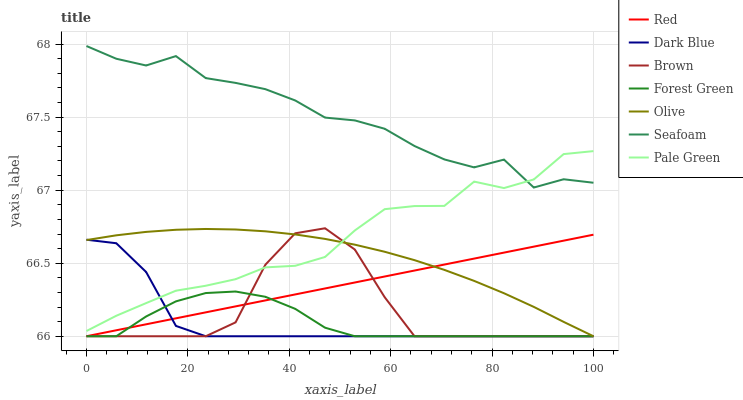Does Dark Blue have the minimum area under the curve?
Answer yes or no. Yes. Does Seafoam have the maximum area under the curve?
Answer yes or no. Yes. Does Seafoam have the minimum area under the curve?
Answer yes or no. No. Does Dark Blue have the maximum area under the curve?
Answer yes or no. No. Is Red the smoothest?
Answer yes or no. Yes. Is Seafoam the roughest?
Answer yes or no. Yes. Is Dark Blue the smoothest?
Answer yes or no. No. Is Dark Blue the roughest?
Answer yes or no. No. Does Brown have the lowest value?
Answer yes or no. Yes. Does Seafoam have the lowest value?
Answer yes or no. No. Does Seafoam have the highest value?
Answer yes or no. Yes. Does Dark Blue have the highest value?
Answer yes or no. No. Is Olive less than Seafoam?
Answer yes or no. Yes. Is Pale Green greater than Forest Green?
Answer yes or no. Yes. Does Brown intersect Olive?
Answer yes or no. Yes. Is Brown less than Olive?
Answer yes or no. No. Is Brown greater than Olive?
Answer yes or no. No. Does Olive intersect Seafoam?
Answer yes or no. No. 